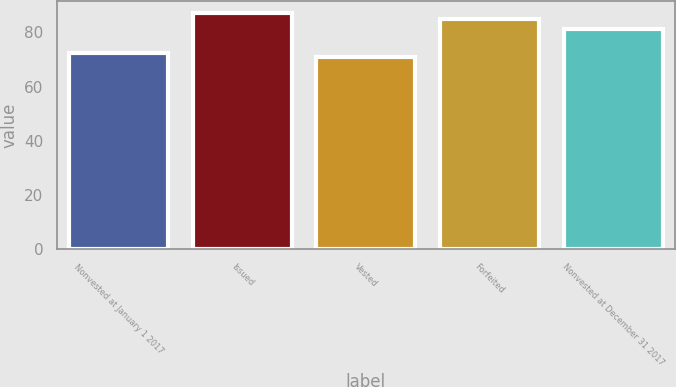<chart> <loc_0><loc_0><loc_500><loc_500><bar_chart><fcel>Nonvested at January 1 2017<fcel>Issued<fcel>Vested<fcel>Forfeited<fcel>Nonvested at December 31 2017<nl><fcel>72.52<fcel>87.09<fcel>70.9<fcel>84.97<fcel>81.13<nl></chart> 